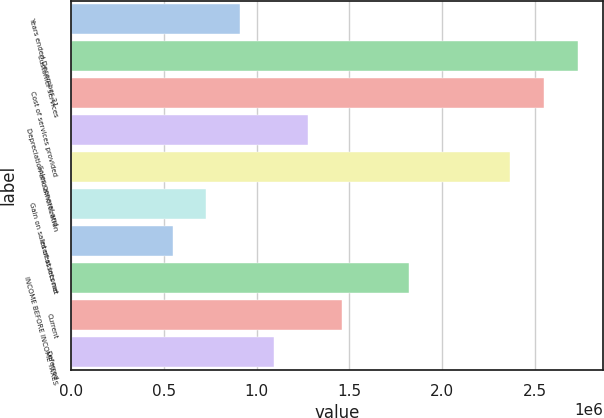Convert chart to OTSL. <chart><loc_0><loc_0><loc_500><loc_500><bar_chart><fcel>Years ended December 31<fcel>Customer services<fcel>Cost of services provided<fcel>Depreciation and amortization<fcel>Sales general and<fcel>Gain on sales of assets net<fcel>Interest income<fcel>INCOME BEFORE INCOME TAXES<fcel>Current<fcel>Deferred<nl><fcel>910783<fcel>2.73235e+06<fcel>2.55019e+06<fcel>1.2751e+06<fcel>2.36803e+06<fcel>728626<fcel>546470<fcel>1.82156e+06<fcel>1.45725e+06<fcel>1.09294e+06<nl></chart> 